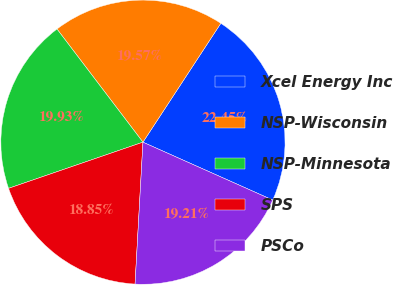Convert chart. <chart><loc_0><loc_0><loc_500><loc_500><pie_chart><fcel>Xcel Energy Inc<fcel>NSP-Wisconsin<fcel>NSP-Minnesota<fcel>SPS<fcel>PSCo<nl><fcel>22.45%<fcel>19.57%<fcel>19.93%<fcel>18.85%<fcel>19.21%<nl></chart> 